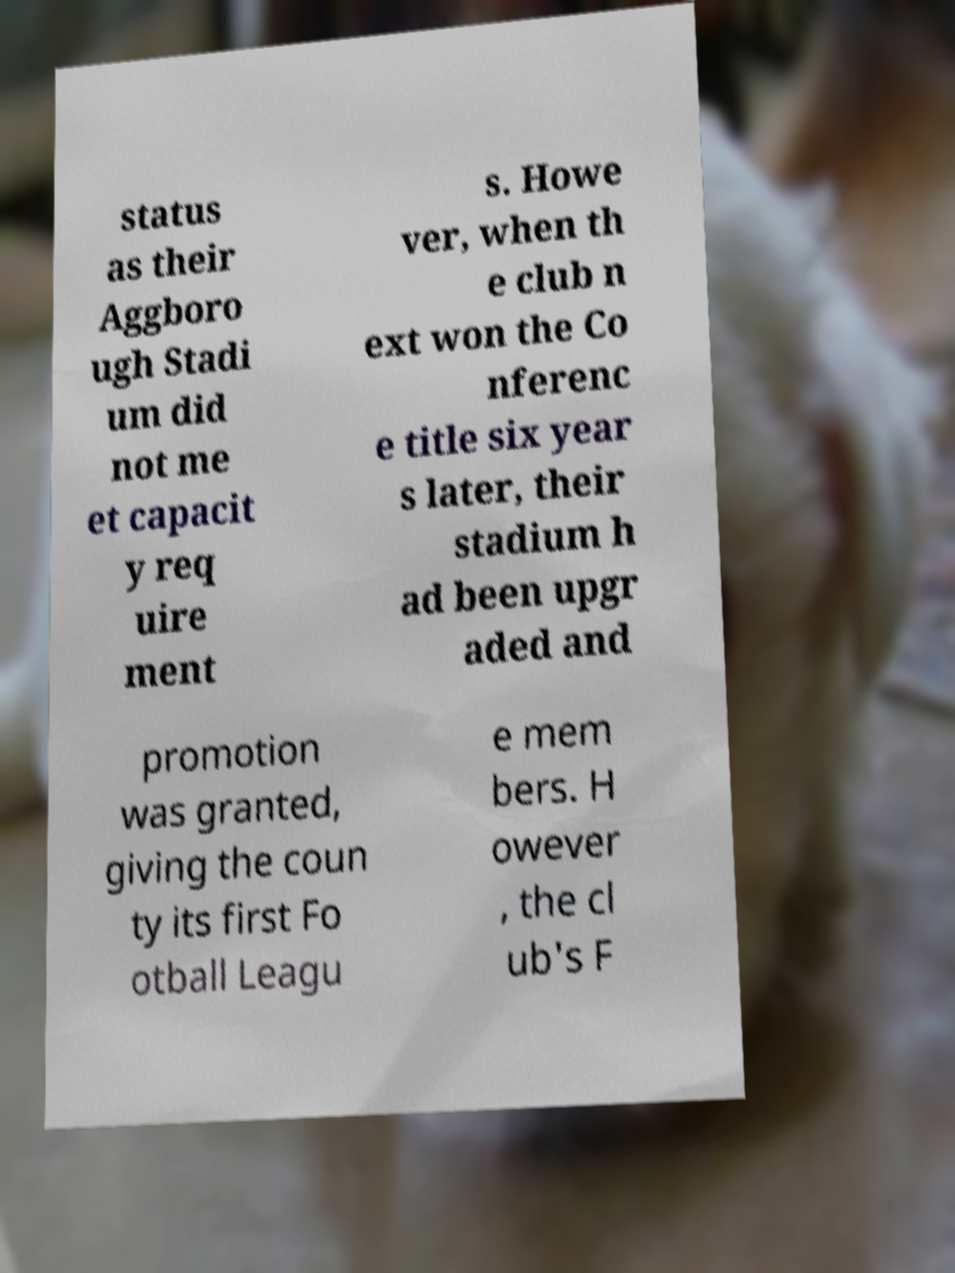Can you accurately transcribe the text from the provided image for me? status as their Aggboro ugh Stadi um did not me et capacit y req uire ment s. Howe ver, when th e club n ext won the Co nferenc e title six year s later, their stadium h ad been upgr aded and promotion was granted, giving the coun ty its first Fo otball Leagu e mem bers. H owever , the cl ub's F 